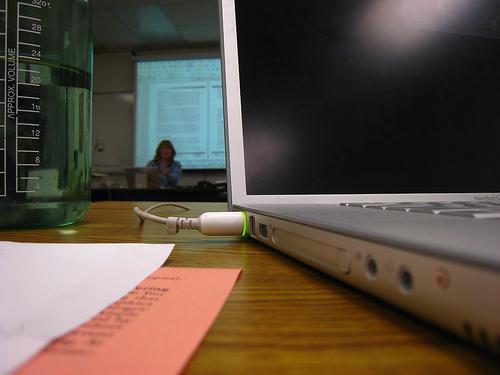How many people sitting?
Give a very brief answer. 1. 